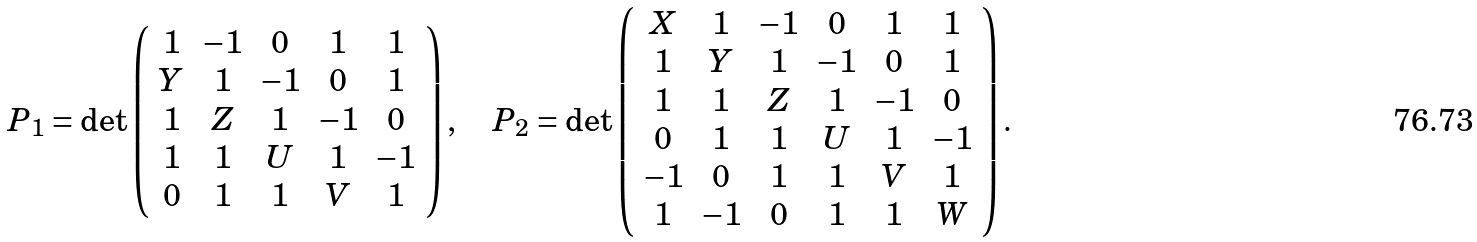Convert formula to latex. <formula><loc_0><loc_0><loc_500><loc_500>P _ { 1 } = \det \left ( \begin{array} { c c c c c } 1 & - 1 & 0 & 1 & 1 \\ Y & 1 & - 1 & 0 & 1 \\ 1 & Z & 1 & - 1 & 0 \\ 1 & 1 & U & 1 & - 1 \\ 0 & 1 & 1 & V & 1 \\ \end{array} \right ) , \quad P _ { 2 } = \det \left ( \begin{array} { c c c c c c } X & 1 & - 1 & 0 & 1 & 1 \\ 1 & Y & 1 & - 1 & 0 & 1 \\ 1 & 1 & Z & 1 & - 1 & 0 \\ 0 & 1 & 1 & U & 1 & - 1 \\ - 1 & 0 & 1 & 1 & V & 1 \\ 1 & - 1 & 0 & 1 & 1 & W \\ \end{array} \right ) .</formula> 